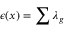Convert formula to latex. <formula><loc_0><loc_0><loc_500><loc_500>\epsilon ( x ) = \sum \lambda _ { g }</formula> 